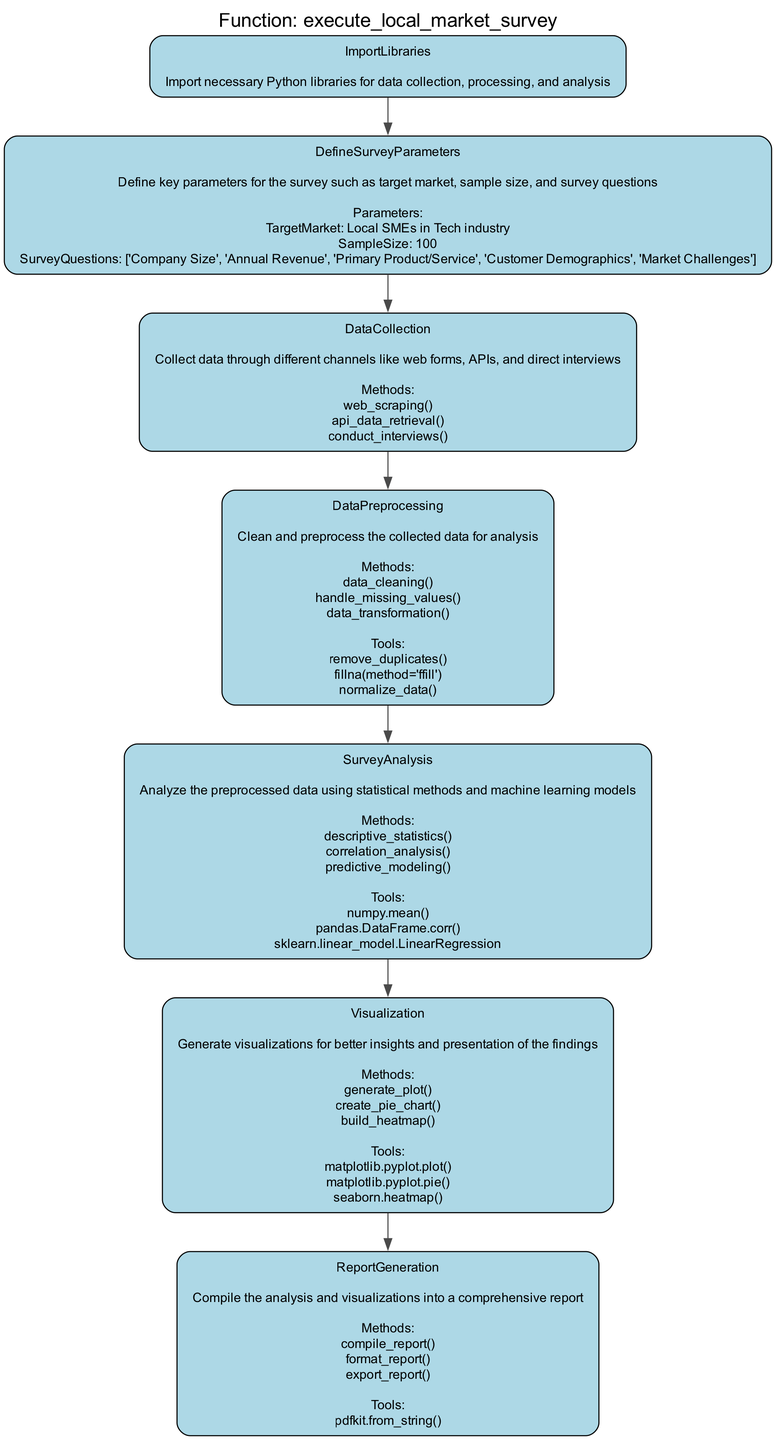What is the first step in the local market survey execution? The first step listed in the diagram is "ImportLibraries", which sets the stage by bringing in necessary Python libraries for the entire operation.
Answer: ImportLibraries How many steps are there in the flowchart? By examining the diagram, we can count a total of seven steps, each representing a part of the execution process.
Answer: 7 What is the target market defined in the survey parameters? The diagram specifies the target market as "Local SMEs in Tech industry", which highlights the focus of the survey.
Answer: Local SMEs in Tech industry Which step involves collecting data? The step labeled "DataCollection" is specifically intended for gathering information through various channels.
Answer: DataCollection What methods are used during the survey analysis step? The survey analysis step utilizes methods including "descriptive_statistics", "correlation_analysis", and "predictive_modeling" to analyze the data collected.
Answer: descriptive_statistics, correlation_analysis, predictive_modeling What is the last step in the local market survey execution process? The final step in the flowchart is "ReportGeneration", which involves compiling the analysis and visualizations into a comprehensive report.
Answer: ReportGeneration How does the DataPreprocessing step interact with the DataCollection step? The DataPreprocessing step follows the DataCollection step, indicating it directly processes the data that was gathered to prepare it for analysis.
Answer: Directly follows Which tools are utilized for visualization? The visualization step utilizes tools like "matplotlib.pyplot.plot", "matplotlib.pyplot.pie", and "seaborn.heatmap" to create visual outputs from the analysis.
Answer: matplotlib.pyplot.plot, matplotlib.pyplot.pie, seaborn.heatmap 